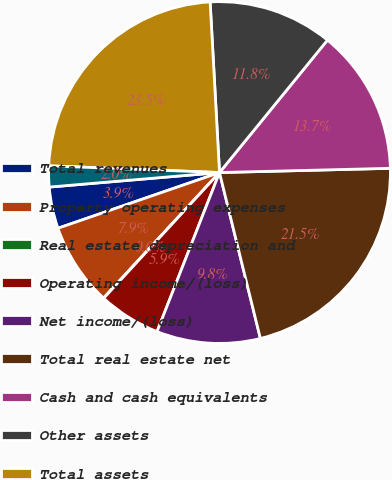Convert chart. <chart><loc_0><loc_0><loc_500><loc_500><pie_chart><fcel>Total revenues<fcel>Property operating expenses<fcel>Real estate depreciation and<fcel>Operating income/(loss)<fcel>Net income/(loss)<fcel>Total real estate net<fcel>Cash and cash equivalents<fcel>Other assets<fcel>Total assets<fcel>Amount due to/(from) UDR<nl><fcel>3.93%<fcel>7.85%<fcel>0.02%<fcel>5.89%<fcel>9.8%<fcel>21.55%<fcel>13.72%<fcel>11.76%<fcel>23.5%<fcel>1.98%<nl></chart> 